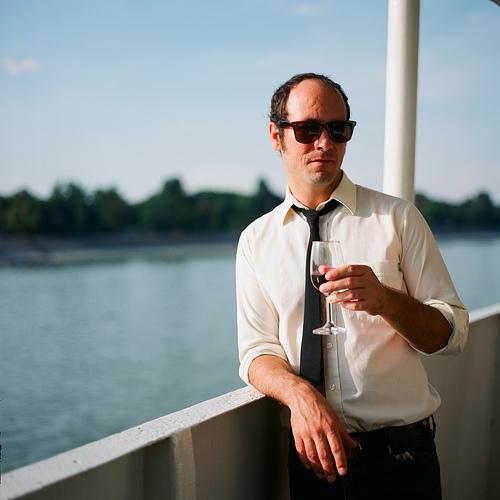Is he wearing a suit?
Be succinct. No. What kind of glass is the man holding?
Be succinct. Wine. What color is the man's tie?
Answer briefly. Black. 